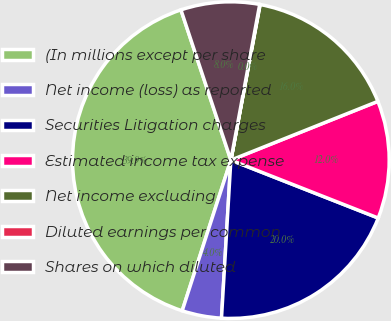<chart> <loc_0><loc_0><loc_500><loc_500><pie_chart><fcel>(In millions except per share<fcel>Net income (loss) as reported<fcel>Securities Litigation charges<fcel>Estimated income tax expense<fcel>Net income excluding<fcel>Diluted earnings per common<fcel>Shares on which diluted<nl><fcel>39.92%<fcel>4.03%<fcel>19.98%<fcel>12.01%<fcel>15.99%<fcel>0.04%<fcel>8.02%<nl></chart> 